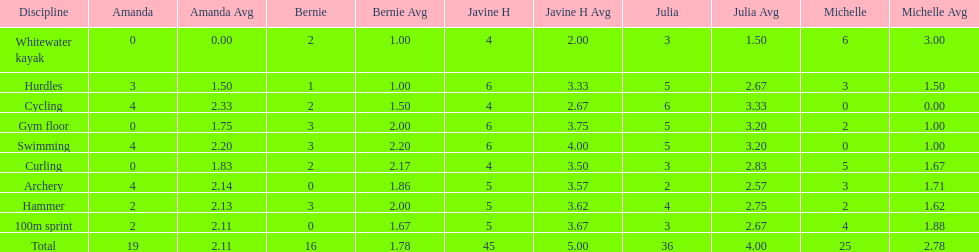Would you be able to parse every entry in this table? {'header': ['Discipline', 'Amanda', 'Amanda Avg', 'Bernie', 'Bernie Avg', 'Javine H', 'Javine H Avg', 'Julia', 'Julia Avg', 'Michelle', 'Michelle Avg'], 'rows': [['Whitewater kayak', '0', '0.00', '2', '1.00', '4', '2.00', '3', '1.50', '6', '3.00'], ['Hurdles', '3', '1.50', '1', '1.00', '6', '3.33', '5', '2.67', '3', '1.50'], ['Cycling', '4', '2.33', '2', '1.50', '4', '2.67', '6', '3.33', '0', '0.00'], ['Gym floor', '0', '1.75', '3', '2.00', '6', '3.75', '5', '3.20', '2', '1.00'], ['Swimming', '4', '2.20', '3', '2.20', '6', '4.00', '5', '3.20', '0', '1.00'], ['Curling', '0', '1.83', '2', '2.17', '4', '3.50', '3', '2.83', '5', '1.67'], ['Archery', '4', '2.14', '0', '1.86', '5', '3.57', '2', '2.57', '3', '1.71'], ['Hammer', '2', '2.13', '3', '2.00', '5', '3.62', '4', '2.75', '2', '1.62'], ['100m sprint', '2', '2.11', '0', '1.67', '5', '3.67', '3', '2.67', '4', '1.88'], ['Total', '19', '2.11', '16', '1.78', '45', '5.00', '36', '4.00', '25', '2.78']]} Who had her best score in cycling? Julia. 